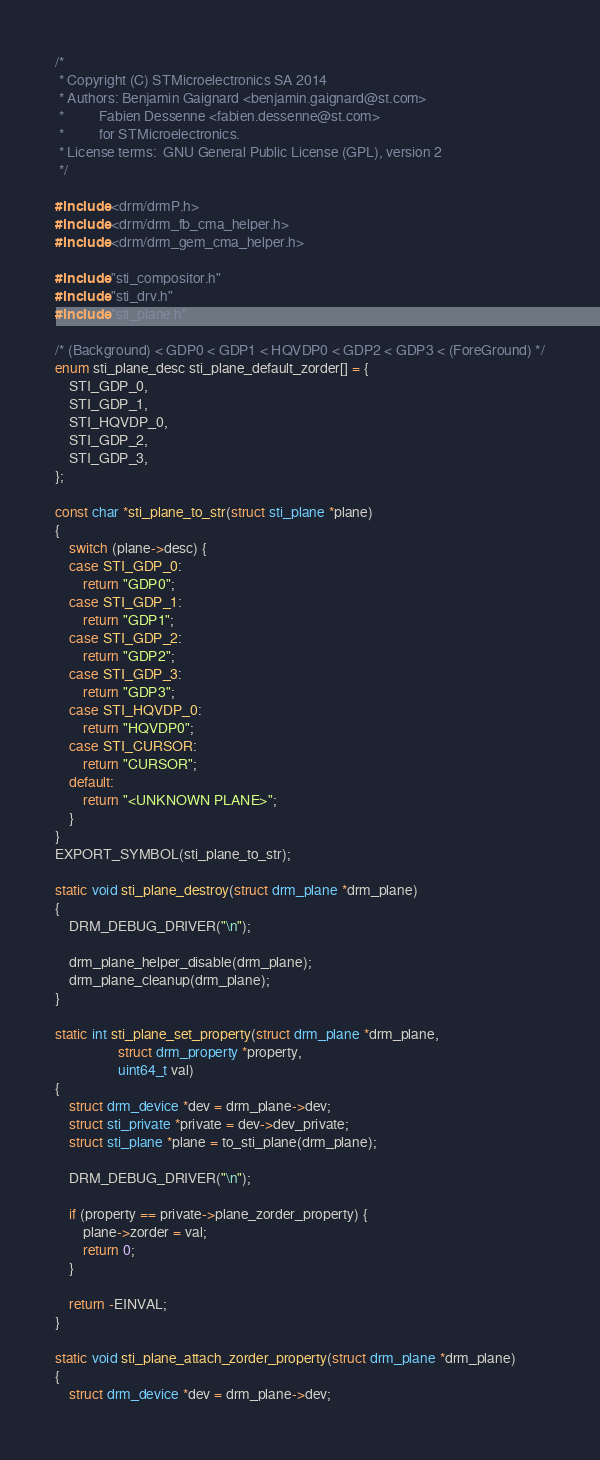<code> <loc_0><loc_0><loc_500><loc_500><_C_>/*
 * Copyright (C) STMicroelectronics SA 2014
 * Authors: Benjamin Gaignard <benjamin.gaignard@st.com>
 *          Fabien Dessenne <fabien.dessenne@st.com>
 *          for STMicroelectronics.
 * License terms:  GNU General Public License (GPL), version 2
 */

#include <drm/drmP.h>
#include <drm/drm_fb_cma_helper.h>
#include <drm/drm_gem_cma_helper.h>

#include "sti_compositor.h"
#include "sti_drv.h"
#include "sti_plane.h"

/* (Background) < GDP0 < GDP1 < HQVDP0 < GDP2 < GDP3 < (ForeGround) */
enum sti_plane_desc sti_plane_default_zorder[] = {
	STI_GDP_0,
	STI_GDP_1,
	STI_HQVDP_0,
	STI_GDP_2,
	STI_GDP_3,
};

const char *sti_plane_to_str(struct sti_plane *plane)
{
	switch (plane->desc) {
	case STI_GDP_0:
		return "GDP0";
	case STI_GDP_1:
		return "GDP1";
	case STI_GDP_2:
		return "GDP2";
	case STI_GDP_3:
		return "GDP3";
	case STI_HQVDP_0:
		return "HQVDP0";
	case STI_CURSOR:
		return "CURSOR";
	default:
		return "<UNKNOWN PLANE>";
	}
}
EXPORT_SYMBOL(sti_plane_to_str);

static void sti_plane_destroy(struct drm_plane *drm_plane)
{
	DRM_DEBUG_DRIVER("\n");

	drm_plane_helper_disable(drm_plane);
	drm_plane_cleanup(drm_plane);
}

static int sti_plane_set_property(struct drm_plane *drm_plane,
				  struct drm_property *property,
				  uint64_t val)
{
	struct drm_device *dev = drm_plane->dev;
	struct sti_private *private = dev->dev_private;
	struct sti_plane *plane = to_sti_plane(drm_plane);

	DRM_DEBUG_DRIVER("\n");

	if (property == private->plane_zorder_property) {
		plane->zorder = val;
		return 0;
	}

	return -EINVAL;
}

static void sti_plane_attach_zorder_property(struct drm_plane *drm_plane)
{
	struct drm_device *dev = drm_plane->dev;</code> 